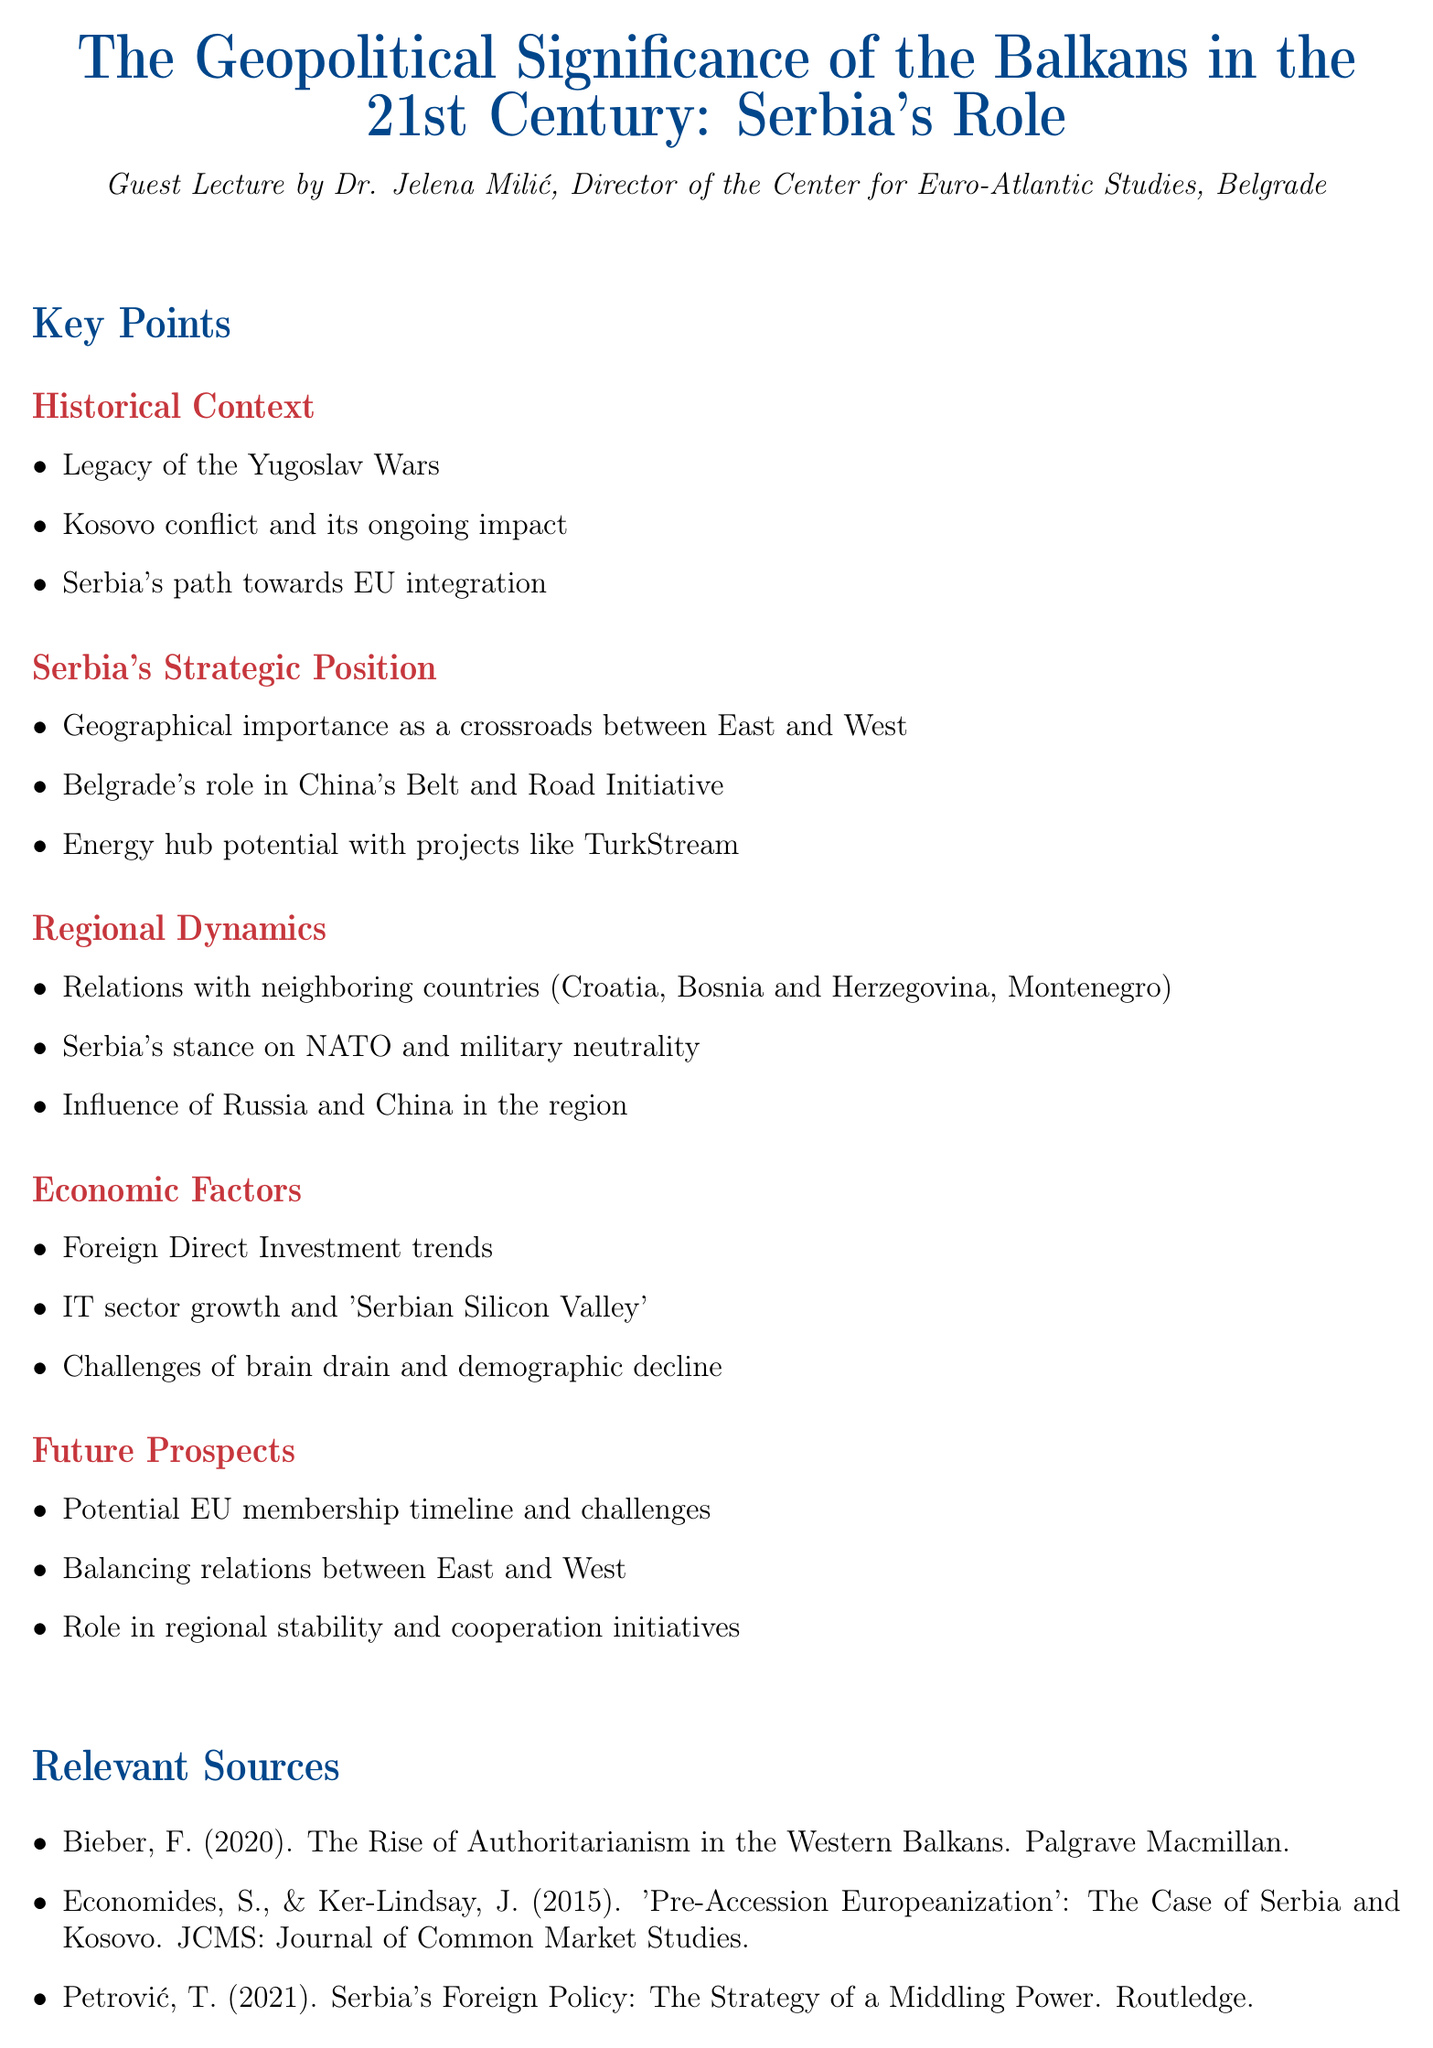What is the title of the lecture? The title is explicitly stated at the beginning of the document, presenting the focus of the guest lecture.
Answer: The Geopolitical Significance of the Balkans in the 21st Century: Serbia's Role Who is the lecturer? The lecturer's name and position are mentioned in the opening section, giving details about their expertise.
Answer: Dr. Jelena Milić What are the three key areas of Historical Context? The details listed under Historical Context include legacy, conflict, and integration, summarizing Serbia's past.
Answer: Legacy of the Yugoslav Wars, Kosovo conflict and its ongoing impact, Serbia's path towards EU integration What role does Belgrade play in China's Belt and Road Initiative? This detail highlights Serbia's strategic involvement in a significant international project, showcasing geopolitical significance.
Answer: Belgrade's role in China's Belt and Road Initiative What is one challenge facing Serbia in the Economic Factors section? The document lists challenges that Serbia is currently facing in terms of economic growth and workforce sustainability.
Answer: Challenges of brain drain and demographic decline What does Serbia's stance on NATO indicate? This refers to Serbia's position in the context of regional security and military alliances, impacting its international relations.
Answer: Serbia's stance on NATO and military neutrality What potential future prospect is discussed regarding EU membership? The document outlines considerations and possibilities for Serbia's integration into the European Union, indicating its geopolitical aspirations.
Answer: Potential EU membership timeline and challenges What influences Serbia's relations with neighboring countries? This mentions regional dynamics that affect Serbia's diplomatic interactions with its close neighbors, including historical tensions.
Answer: Relations with neighboring countries (Croatia, Bosnia and Herzegovina, Montenegro) Which source discusses authoritarianism in the Western Balkans? The sources listed are pertinent to understanding the geopolitical landscape and issues related to Serbia and its neighbors.
Answer: Bieber, F. (2020). The Rise of Authoritarianism in the Western Balkans. Palgrave Macmillan 